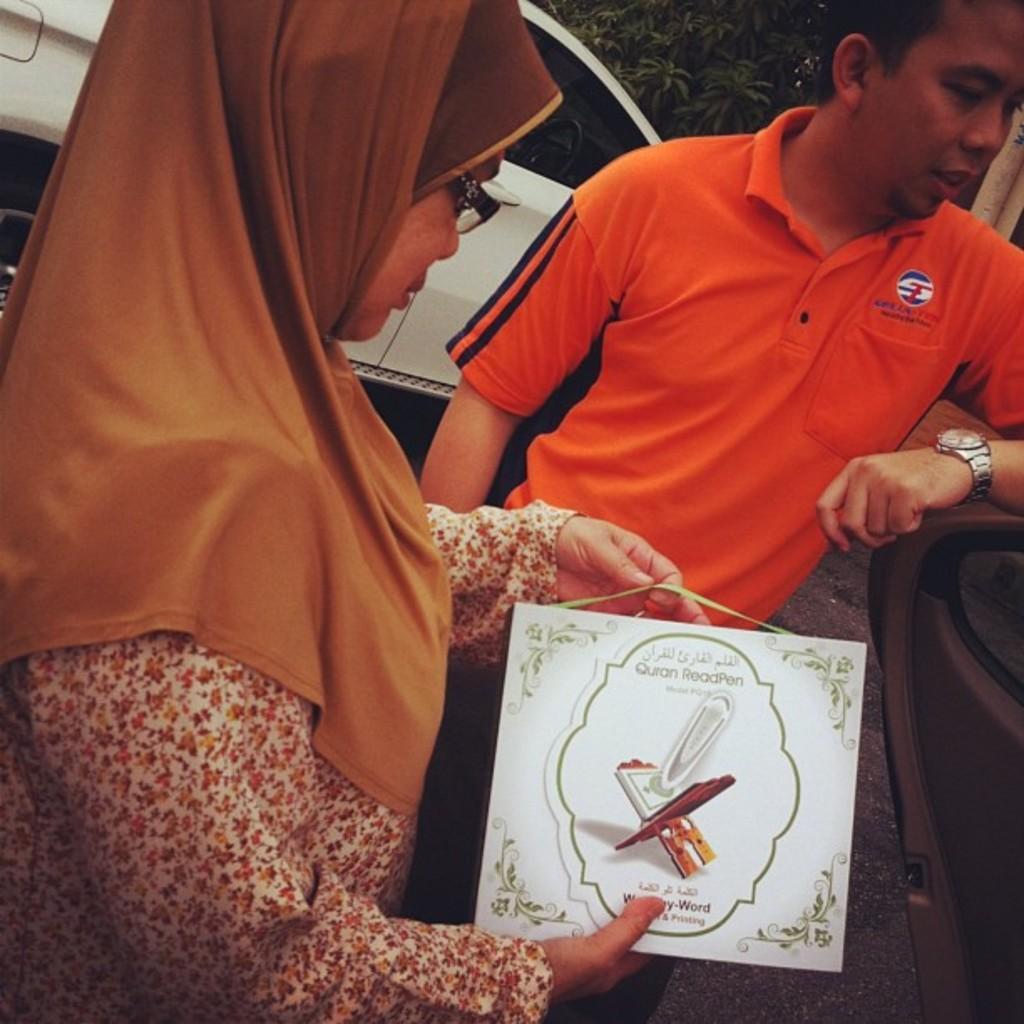How would you summarize this image in a sentence or two? In this image, there are two persons standing. In the background, I can see a vehicle and a tree. 